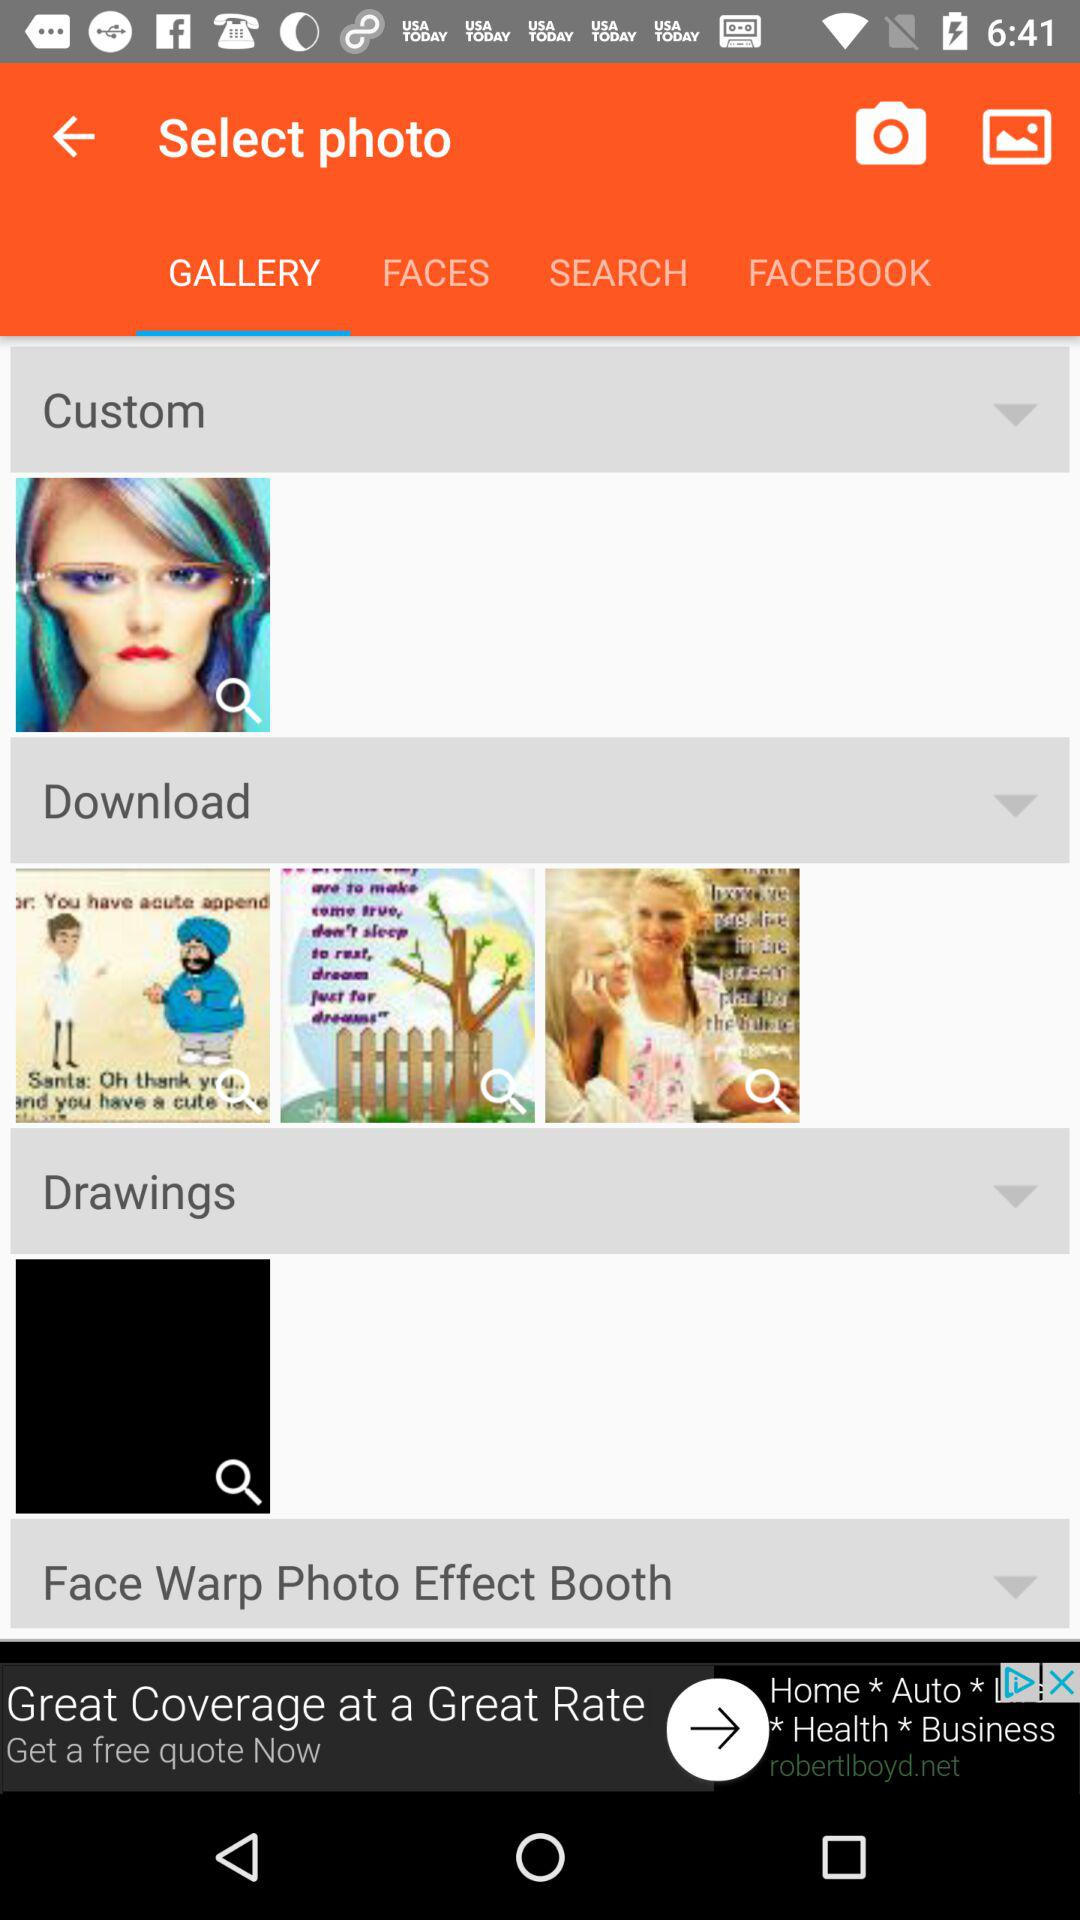Which tab is currently selected? The selected tab is "GALLERY". 